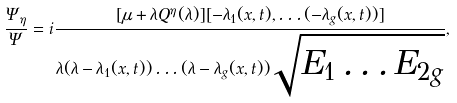Convert formula to latex. <formula><loc_0><loc_0><loc_500><loc_500>\frac { \Psi _ { \eta } } { \Psi } = i \frac { [ \mu + \lambda Q ^ { \eta } ( \lambda ) ] [ - \lambda _ { 1 } ( x , t ) , \dots ( - \lambda _ { g } ( x , t ) ) ] } { \lambda ( \lambda - \lambda _ { 1 } ( x , t ) ) \dots ( \lambda - \lambda _ { g } ( x , t ) ) \sqrt { E _ { 1 } \dots E _ { 2 g } } } ,</formula> 